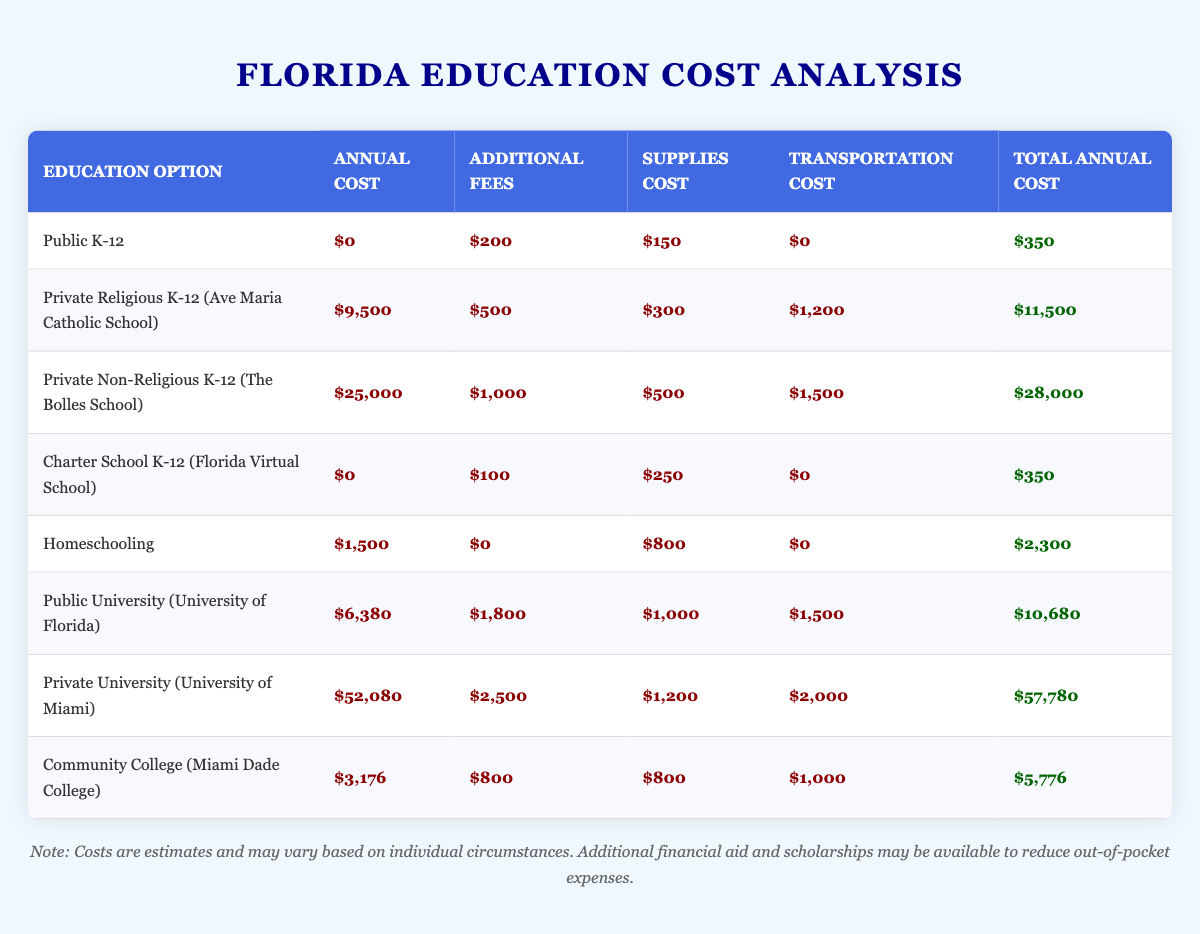What is the total annual cost for a Private Non-Religious K-12 education option? The total annual cost is given in the table. For Private Non-Religious K-12 (The Bolles School), the total annual cost is listed as $28,000.
Answer: $28,000 How much does a Public K-12 education cost in total annually? In the table, the total annual cost for Public K-12 is $350, which is calculated from additional fees of $200 and supplies cost of $150 since there are no annual costs and transportation costs.
Answer: $350 What is the cost difference between Private Religious K-12 and Private Non-Religious K-12? To find the difference, subtract the total cost of Private Religious K-12 ($11,500) from Private Non-Religious K-12 ($28,000). The calculation is $28,000 - $11,500 = $16,500.
Answer: $16,500 Are the costs for Charter School K-12 higher than Public K-12? Public K-12 has a total annual cost of $350, while the total cost for Charter School K-12 is also $350, meaning the costs are equal.
Answer: No How much more expensive is the Private University (University of Miami) compared to Public University (University of Florida)? The total cost for Private University is $57,780 and for Public University is $10,680. The difference is found by subtracting: $57,780 - $10,680 = $47,100.
Answer: $47,100 What is the total annual cost for Homeschooling? The total annual cost for Homeschooling is directly listed in the table as $2,300, calculated from the annual cost of $1,500 and supplies cost of $800.
Answer: $2,300 What is the combined total annual cost for Community College and Public University? The total annual cost for Community College is $5,776 and for Public University, it is $10,680. To find the combined cost, add these two amounts: $5,776 + $10,680 = $16,456.
Answer: $16,456 Does the Private Non-Religious K-12 option have additional fees? The table indicates that Private Non-Religious K-12 (The Bolles School) has additional fees of $1,000 listed.
Answer: Yes What is the maximum annual amount for the Step Up For Students Scholarship? The table specifies that the maximum annual amount for the Step Up For Students Scholarship is $7,000.
Answer: $7,000 